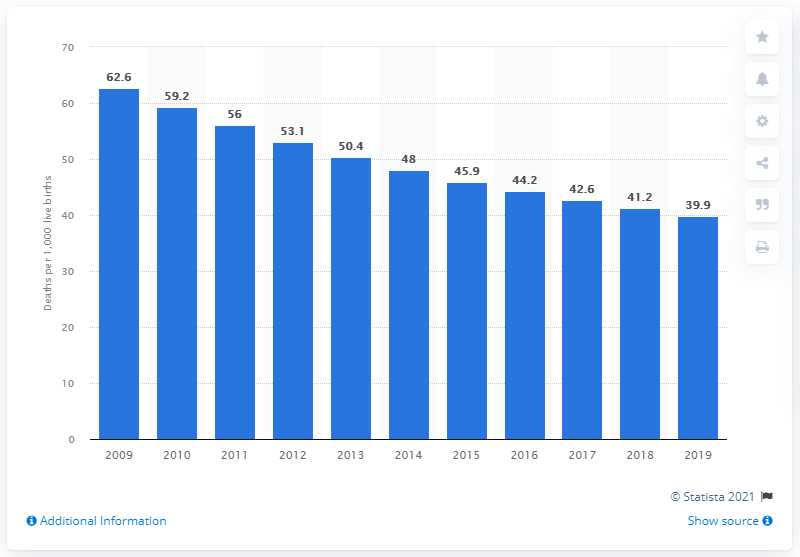Indicate a few pertinent items in this graphic. In 2019, the infant mortality rate in Burundi was 39.9 deaths per 1,000 live births. 